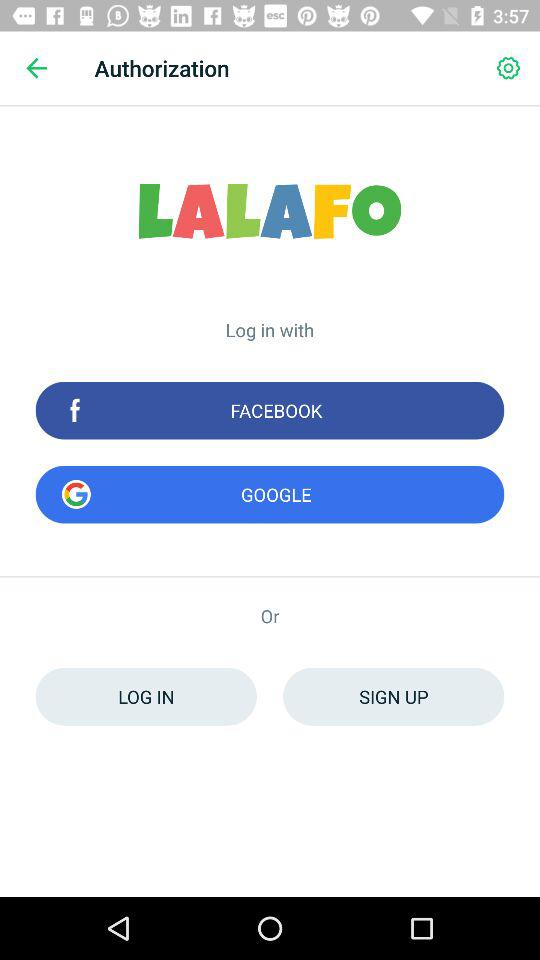What is the application name? The name of the application is "LALAFO". 